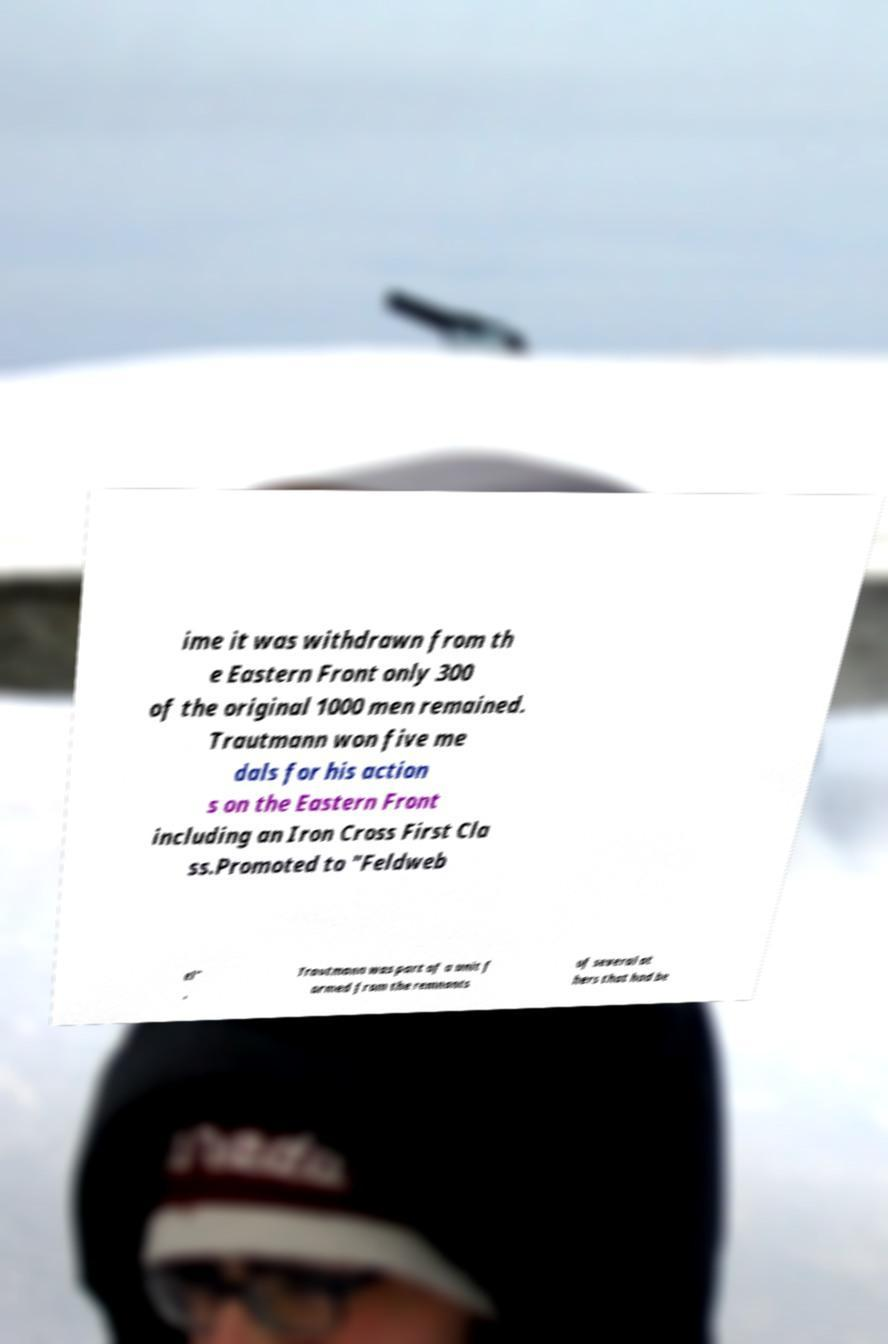For documentation purposes, I need the text within this image transcribed. Could you provide that? ime it was withdrawn from th e Eastern Front only 300 of the original 1000 men remained. Trautmann won five me dals for his action s on the Eastern Front including an Iron Cross First Cla ss.Promoted to "Feldweb el" , Trautmann was part of a unit f ormed from the remnants of several ot hers that had be 